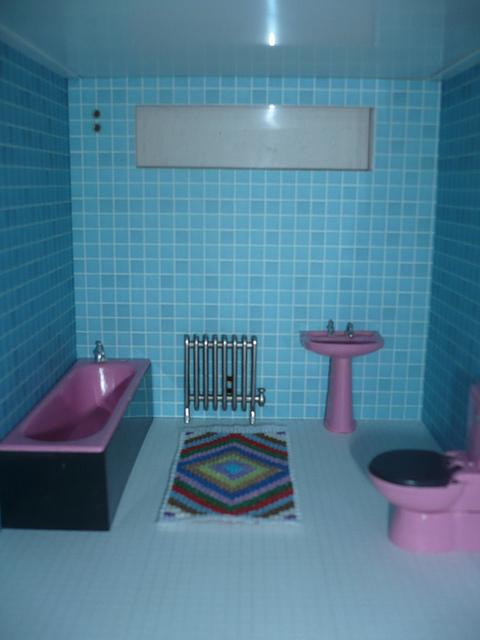Is the toilet seat a different color than the toilet?
Keep it brief. Yes. Is there a rug on the floor?
Quick response, please. Yes. Is this a shower?
Concise answer only. No. What color is the sink?
Keep it brief. Pink. What color is the wall?
Quick response, please. Blue. 